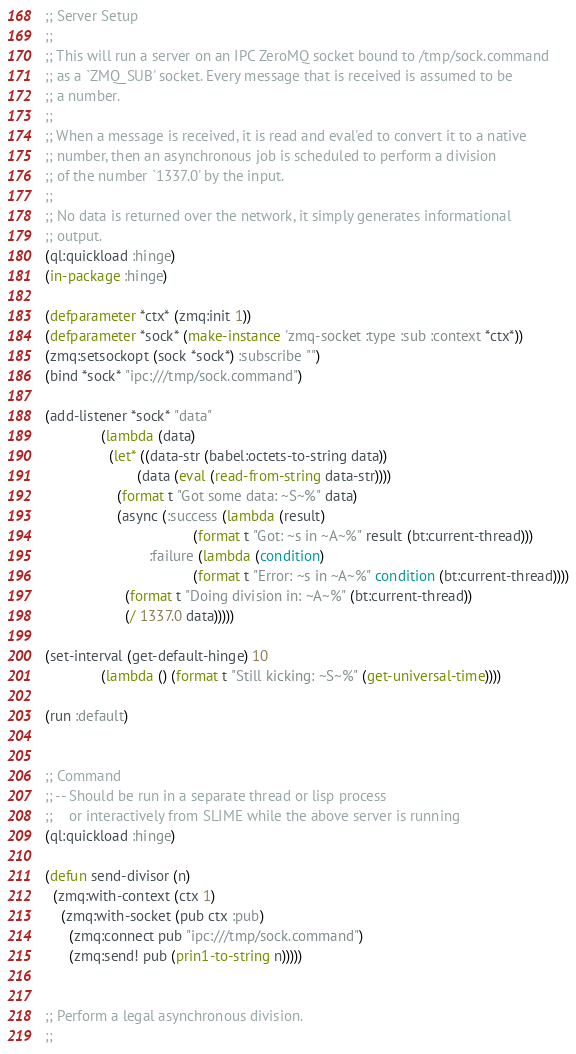Convert code to text. <code><loc_0><loc_0><loc_500><loc_500><_Lisp_>;; Server Setup
;;
;; This will run a server on an IPC ZeroMQ socket bound to /tmp/sock.command
;; as a `ZMQ_SUB' socket. Every message that is received is assumed to be
;; a number.
;;
;; When a message is received, it is read and eval'ed to convert it to a native
;; number, then an asynchronous job is scheduled to perform a division
;; of the number `1337.0' by the input.
;;
;; No data is returned over the network, it simply generates informational
;; output.
(ql:quickload :hinge)
(in-package :hinge)

(defparameter *ctx* (zmq:init 1))
(defparameter *sock* (make-instance 'zmq-socket :type :sub :context *ctx*))
(zmq:setsockopt (sock *sock*) :subscribe "")
(bind *sock* "ipc:///tmp/sock.command")

(add-listener *sock* "data"
              (lambda (data)
                (let* ((data-str (babel:octets-to-string data))
                       (data (eval (read-from-string data-str))))
                  (format t "Got some data: ~S~%" data)
                  (async (:success (lambda (result)
                                     (format t "Got: ~s in ~A~%" result (bt:current-thread)))
                          :failure (lambda (condition)
                                     (format t "Error: ~s in ~A~%" condition (bt:current-thread))))
                    (format t "Doing division in: ~A~%" (bt:current-thread))
                    (/ 1337.0 data)))))

(set-interval (get-default-hinge) 10
              (lambda () (format t "Still kicking: ~S~%" (get-universal-time))))

(run :default)


;; Command
;; -- Should be run in a separate thread or lisp process
;;    or interactively from SLIME while the above server is running
(ql:quickload :hinge)

(defun send-divisor (n)
  (zmq:with-context (ctx 1)
    (zmq:with-socket (pub ctx :pub)
      (zmq:connect pub "ipc:///tmp/sock.command")
      (zmq:send! pub (prin1-to-string n)))))


;; Perform a legal asynchronous division.
;;</code> 